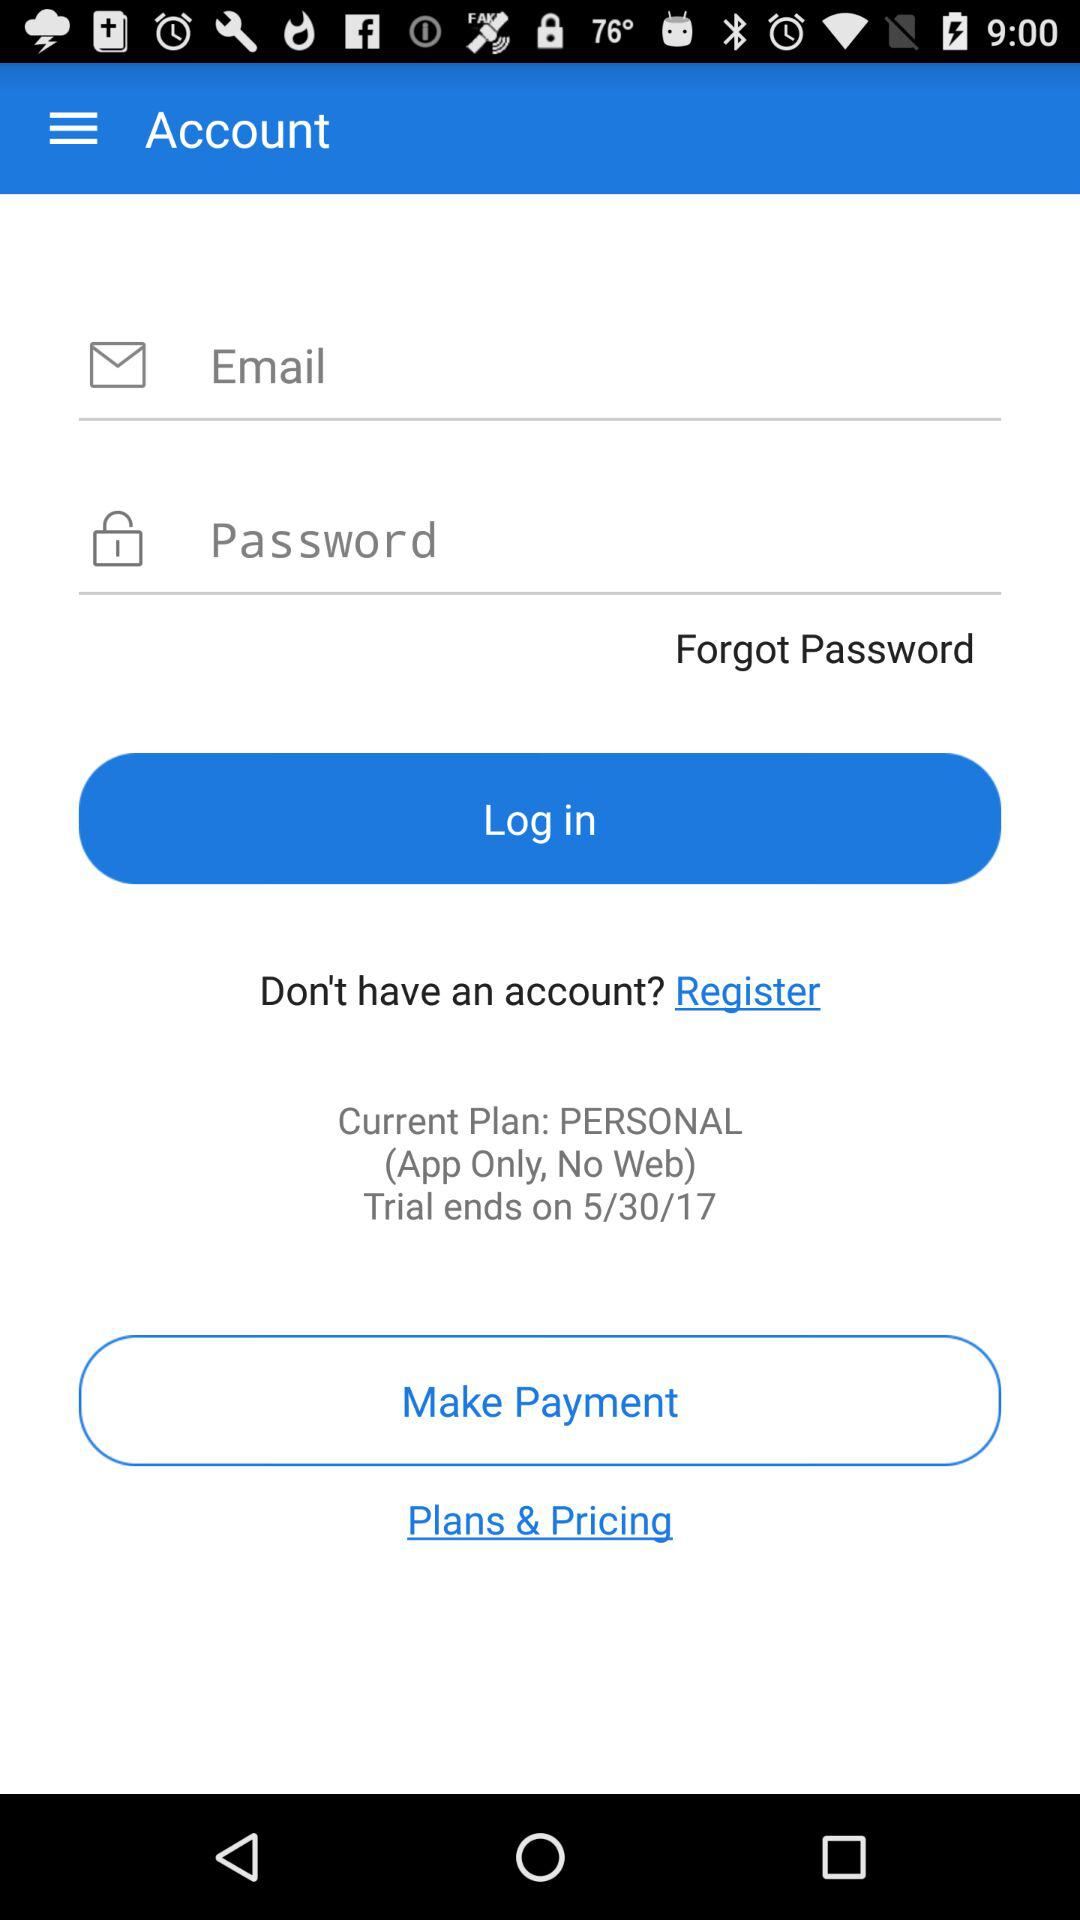What is the current plan? The current plan is "PERSONAL". 